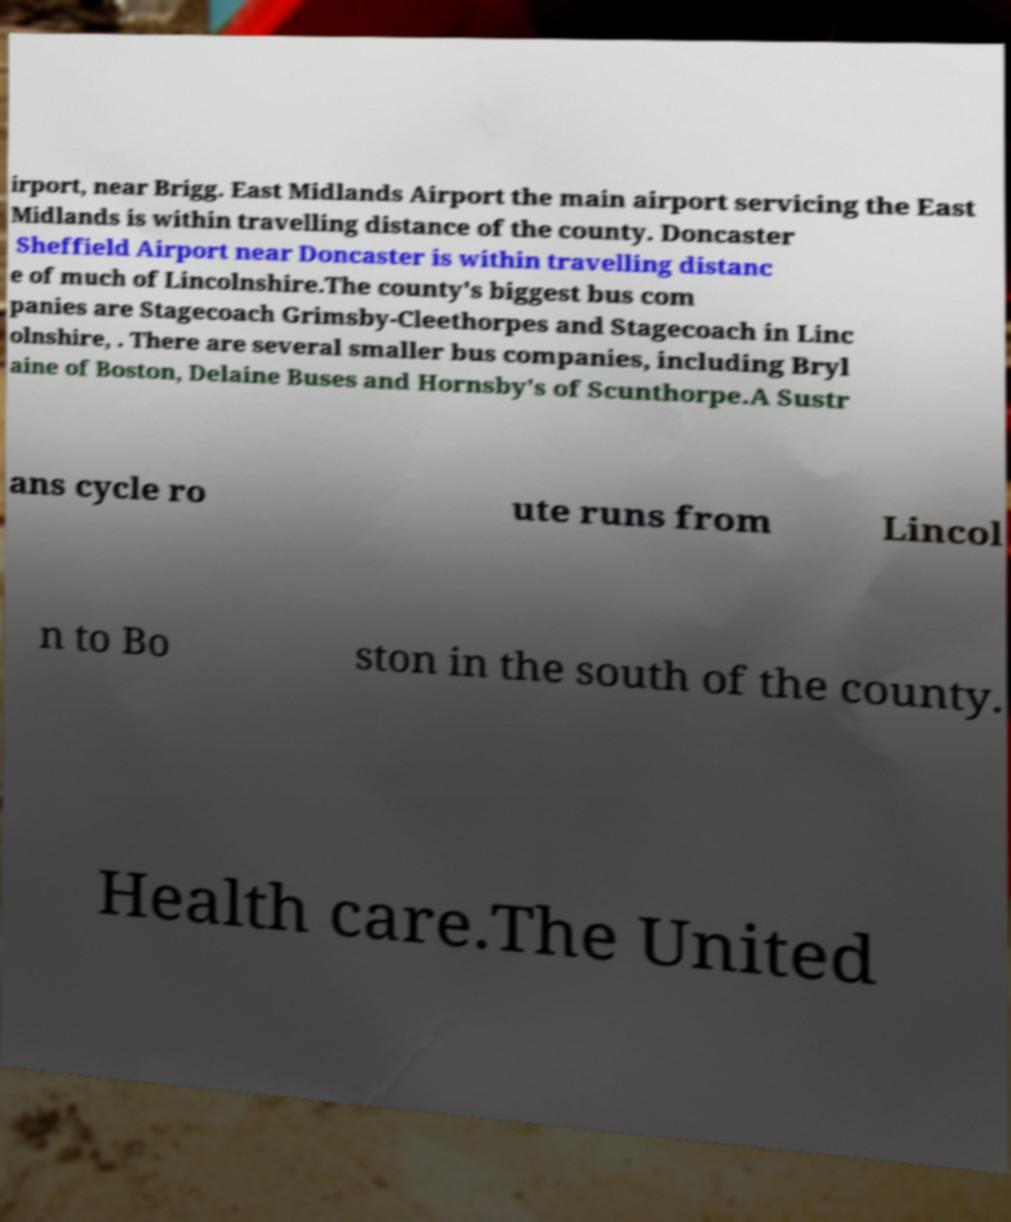For documentation purposes, I need the text within this image transcribed. Could you provide that? irport, near Brigg. East Midlands Airport the main airport servicing the East Midlands is within travelling distance of the county. Doncaster Sheffield Airport near Doncaster is within travelling distanc e of much of Lincolnshire.The county's biggest bus com panies are Stagecoach Grimsby-Cleethorpes and Stagecoach in Linc olnshire, . There are several smaller bus companies, including Bryl aine of Boston, Delaine Buses and Hornsby's of Scunthorpe.A Sustr ans cycle ro ute runs from Lincol n to Bo ston in the south of the county. Health care.The United 